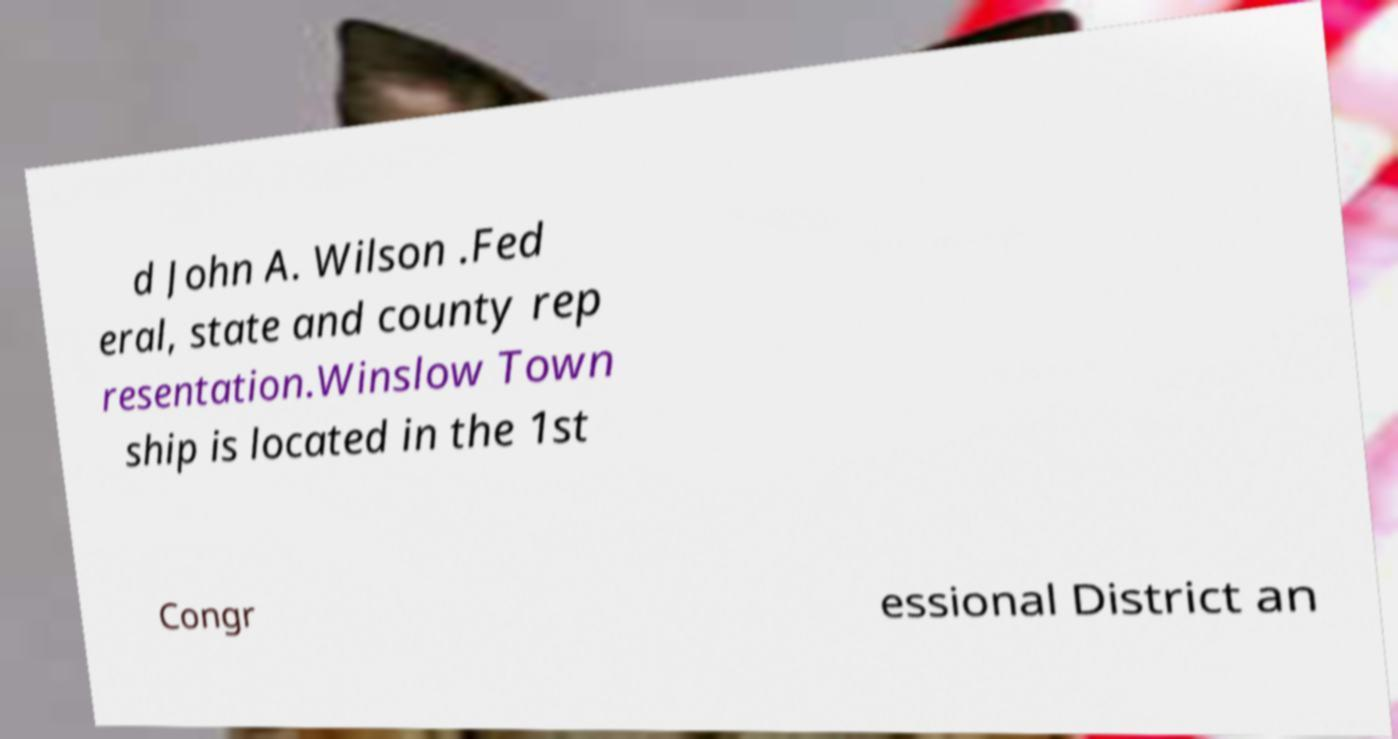Please identify and transcribe the text found in this image. d John A. Wilson .Fed eral, state and county rep resentation.Winslow Town ship is located in the 1st Congr essional District an 